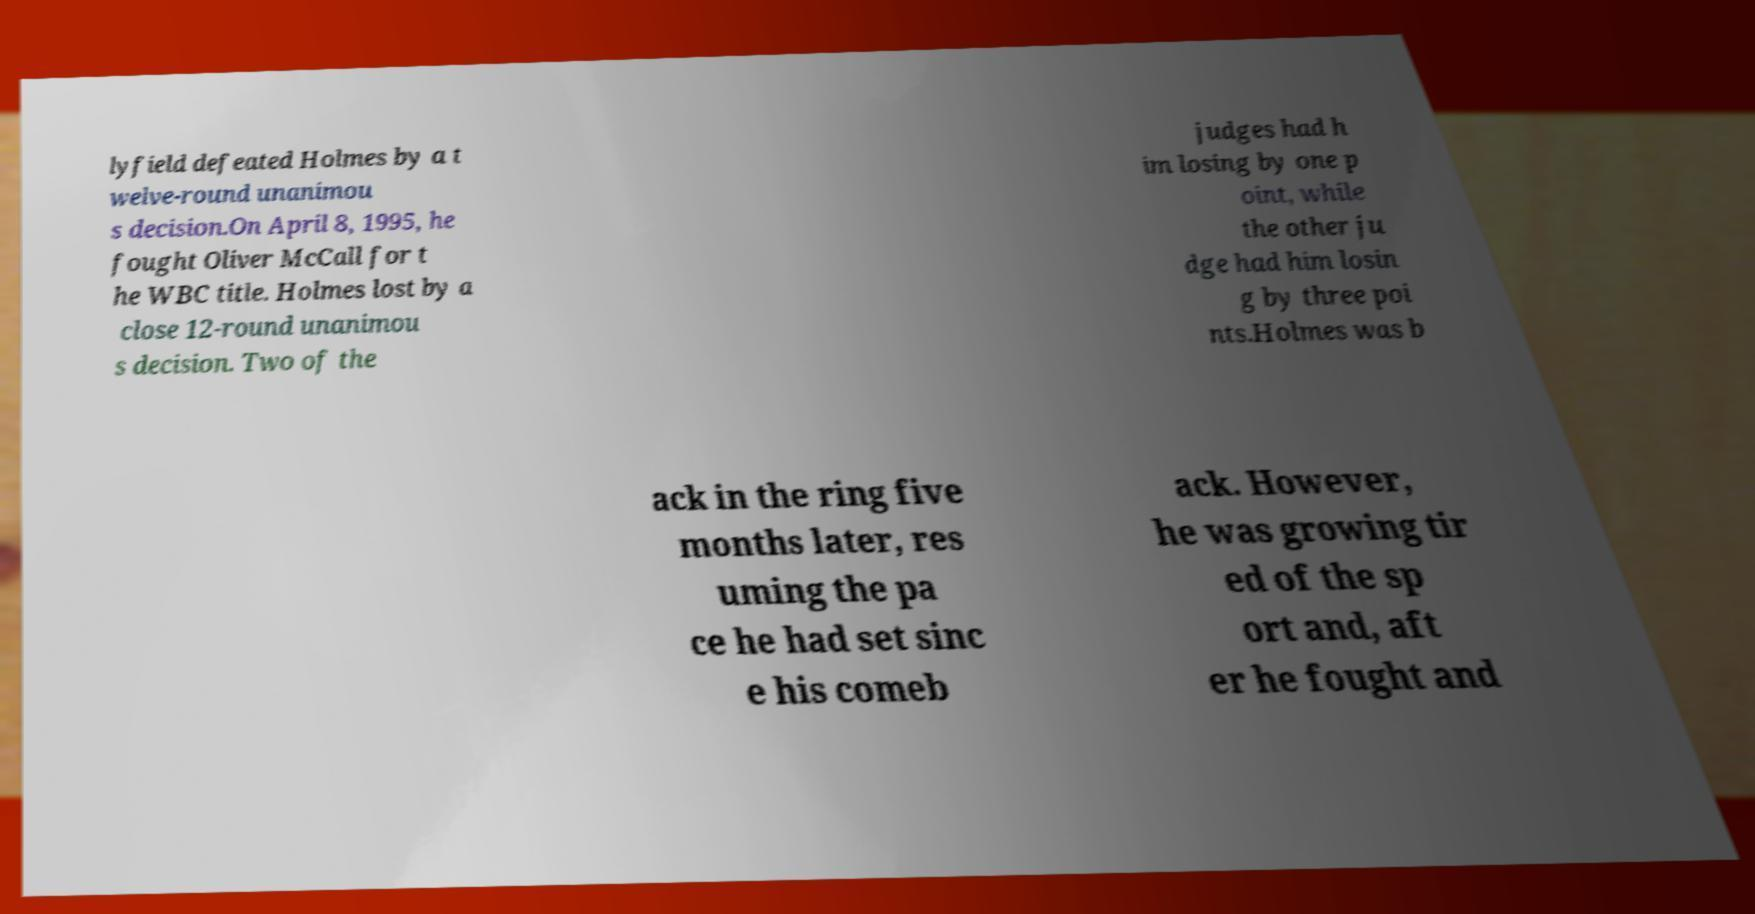There's text embedded in this image that I need extracted. Can you transcribe it verbatim? lyfield defeated Holmes by a t welve-round unanimou s decision.On April 8, 1995, he fought Oliver McCall for t he WBC title. Holmes lost by a close 12-round unanimou s decision. Two of the judges had h im losing by one p oint, while the other ju dge had him losin g by three poi nts.Holmes was b ack in the ring five months later, res uming the pa ce he had set sinc e his comeb ack. However, he was growing tir ed of the sp ort and, aft er he fought and 